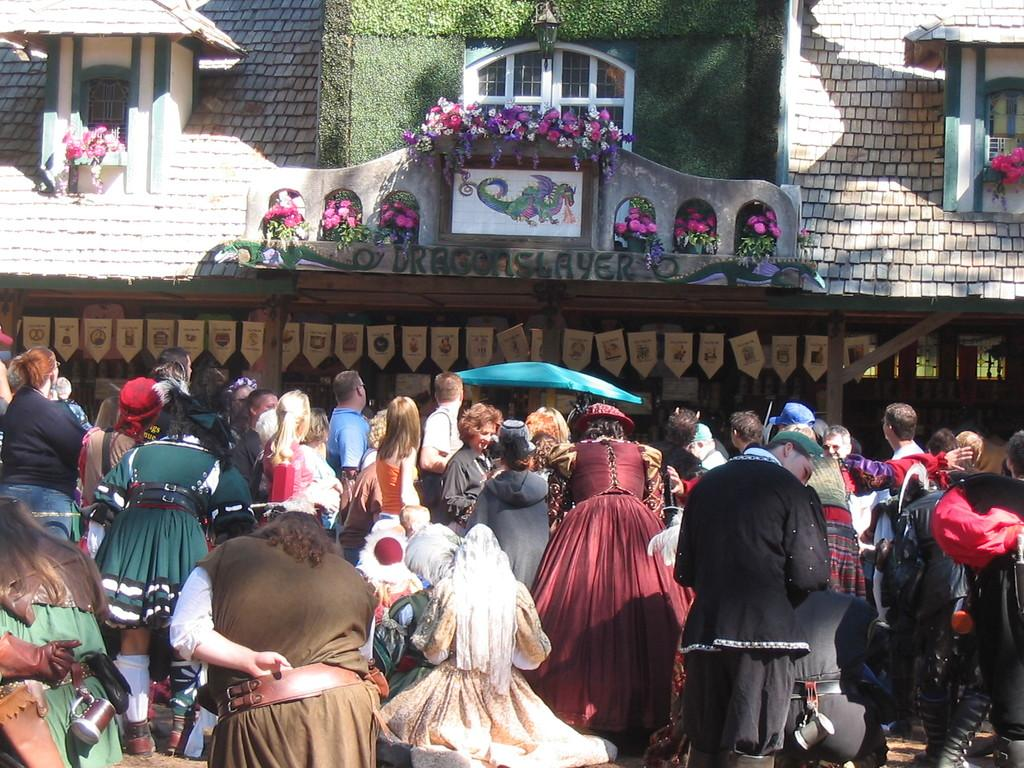How many people are in the image? There is a group of people in the image, but the exact number is not specified. What are some people wearing in the image? Some people are wearing costumes in the image. What can be seen in the background of the image? In the background of the image, there are poles, decorative objects, a wall, glass windows, flowers, and other unspecified things. What is the acoustics like in the image? The image does not provide information about the acoustics; it only shows a group of people and the background. What thought process can be observed in the image? The image does not depict any thought process; it is a static representation of a scene. 